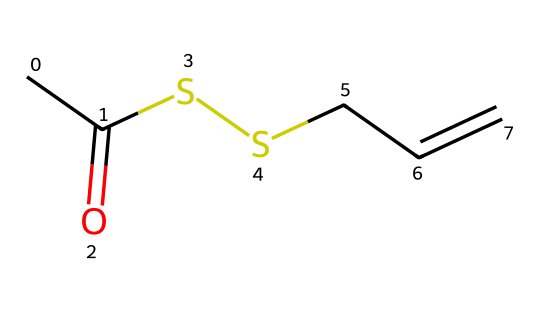how many carbon atoms are in this compound? The SMILES representation shows 'CC', indicating two carbon atoms. This is followed by 'CC', adding another two carbon atoms. Therefore, the total number of carbon atoms is 4.
Answer: 4 what type of functional groups are present in this structure? In the structure, there is a 'CC(=O)' which indicates a carbonyl group (C=O) and 'SS' indicating a disulfide group (-S-S-). So, the functional groups present are a carbonyl (ketone) and disulfide.
Answer: carbonyl and disulfide how many sulfur atoms are present? The 'SS' part of the SMILES reveals two sulfur atoms are connected. Therefore, there are a total of 2 sulfur atoms in the compound.
Answer: 2 what is the characteristic element of organosulfur compounds? The presence of sulfur (indicated by 'S') is the defining characteristic of organosulfur compounds, as they contain carbon (C) bound to sulfur.
Answer: sulfur is this compound likely to have a strong flavor? Yes, many organosulfur compounds are known for their potent flavors and aromas, and this structure, with its carbonyl and disulfide groups, suggests that it would have a strong flavor profile.
Answer: yes what type of bond is formed between the sulfur atoms? The 'SS' portion indicates a single bond connecting the two sulfur atoms. Single bonds are typical for disulfide linkages in organosulfur compounds.
Answer: single bond 